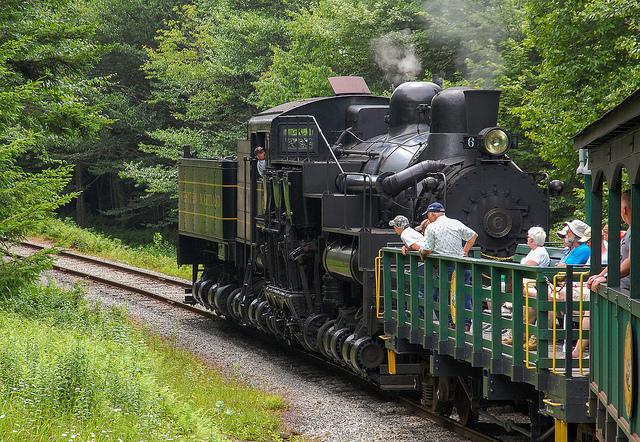Are they going down a hill?
Short answer required. No. How many times do you see the number 6?
Be succinct. 1. Is it wintertime?
Answer briefly. No. 